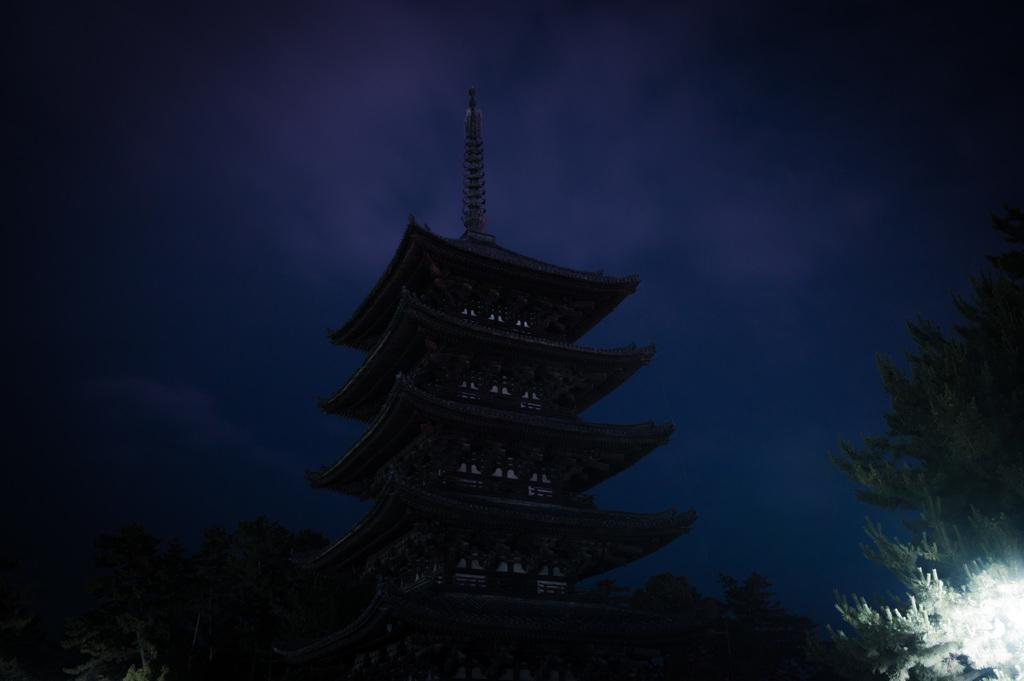What is the main structure in the picture? There is a pagoda in the picture. What can be seen surrounding the pagoda? There are many trees around the pagoda. What time of day is the picture taken? The picture is captured at night time. What type of garden can be seen on top of the pagoda in the image? There is no garden visible on top of the pagoda in the image. 